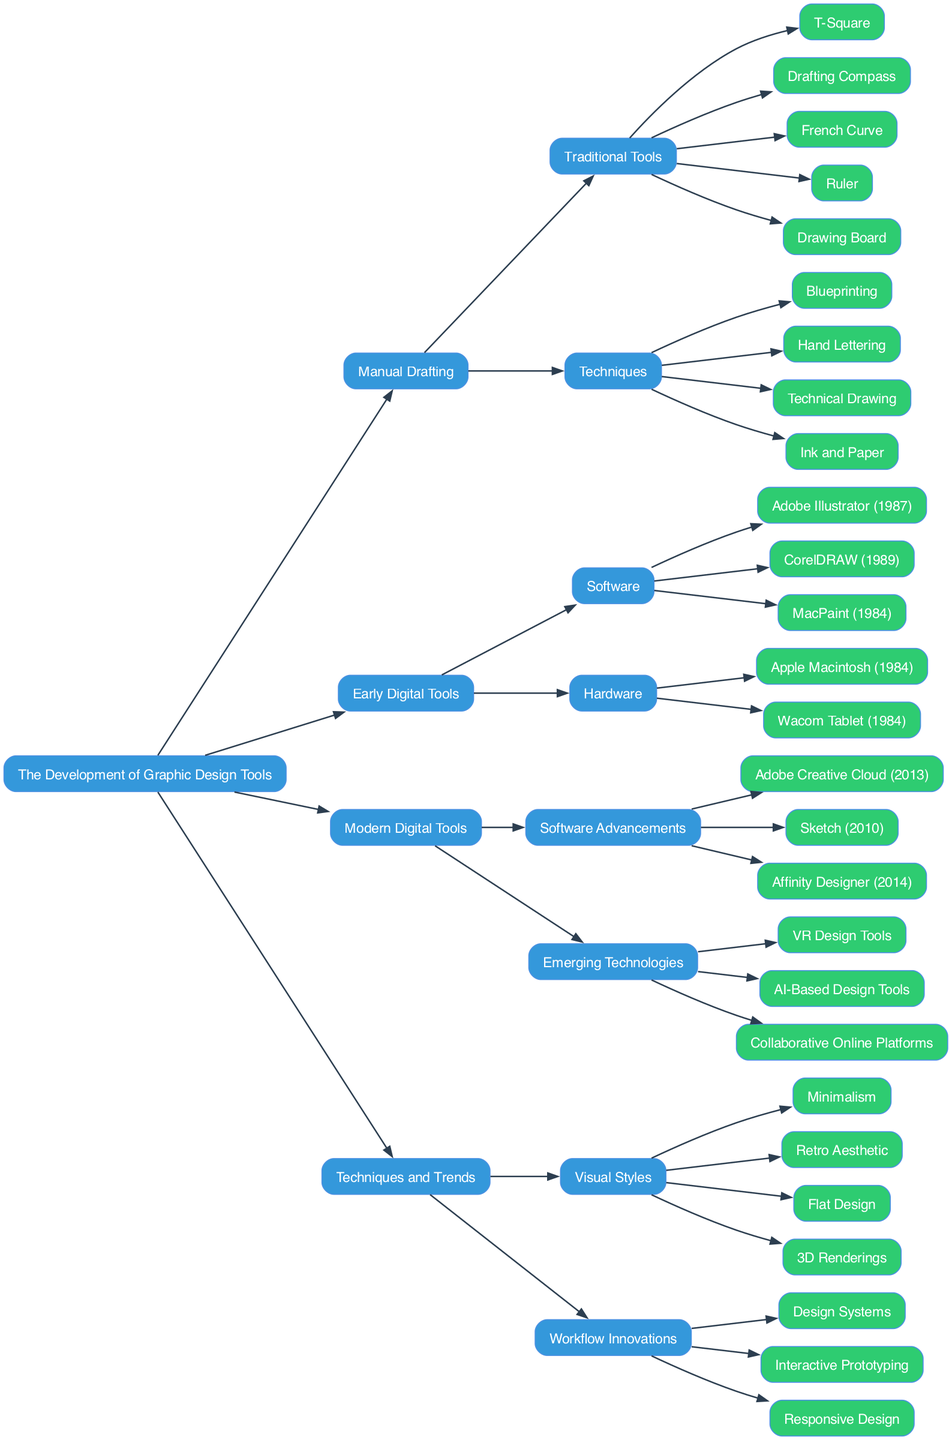What are the primary categories in the diagram? The diagram has four main categories: Manual Drafting, Early Digital Tools, Modern Digital Tools, and Techniques and Trends. These categories are the top-level nodes representing key phases in the development of graphic design tools.
Answer: Manual Drafting, Early Digital Tools, Modern Digital Tools, Techniques and Trends How many traditional tools are listed under Manual Drafting? Under the Manual Drafting category, there are five traditional tools listed: T-Square, Drafting Compass, French Curve, Ruler, and Drawing Board. These are specifically outlined as components of the Manual Drafting section.
Answer: 5 Which software was released first, Adobe Illustrator or CorelDRAW? Adobe Illustrator was released in 1987, while CorelDRAW was released in 1989. Thus, Adobe Illustrator came first, as indicated in the Early Digital Tools section under Software.
Answer: Adobe Illustrator What emerging technology represents the future of design tools in the diagram? The diagram highlights VR Design Tools, AI-Based Design Tools, and Collaborative Online Platforms as emerging technologies. They are categorized under Modern Digital Tools in the Emerging Technologies section, showcasing innovative trends in the design landscape.
Answer: VR Design Tools How many visual styles are identified in the Techniques and Trends category? The Techniques and Trends category contains four visual styles listed: Minimalism, Retro Aesthetic, Flat Design, and 3D Renderings. They emphasize different design approaches and aesthetics prevalent in graphic design.
Answer: 4 Which category has both hardware and software listed? The Early Digital Tools category encompasses both hardware (Apple Macintosh and Wacom Tablet) and software (Adobe Illustrator, CorelDRAW, and MacPaint). This dual representation illustrates the importance of both types of tools in the early stages of digital graphic design.
Answer: Early Digital Tools Which technique under Manual Drafting emphasizes the use of text? Hand Lettering is the technique listed under the Manual Drafting category that emphasizes the use of text, showcasing a traditional method of creating typographic elements by hand.
Answer: Hand Lettering What is the latest software advancement mentioned in the Modern Digital Tools section? Adobe Creative Cloud is the latest software advancement mentioned, released in 2013, and it is part of the Software Advancements subcategory within Modern Digital Tools, indicating its significance in contemporary graphic design practices.
Answer: Adobe Creative Cloud 